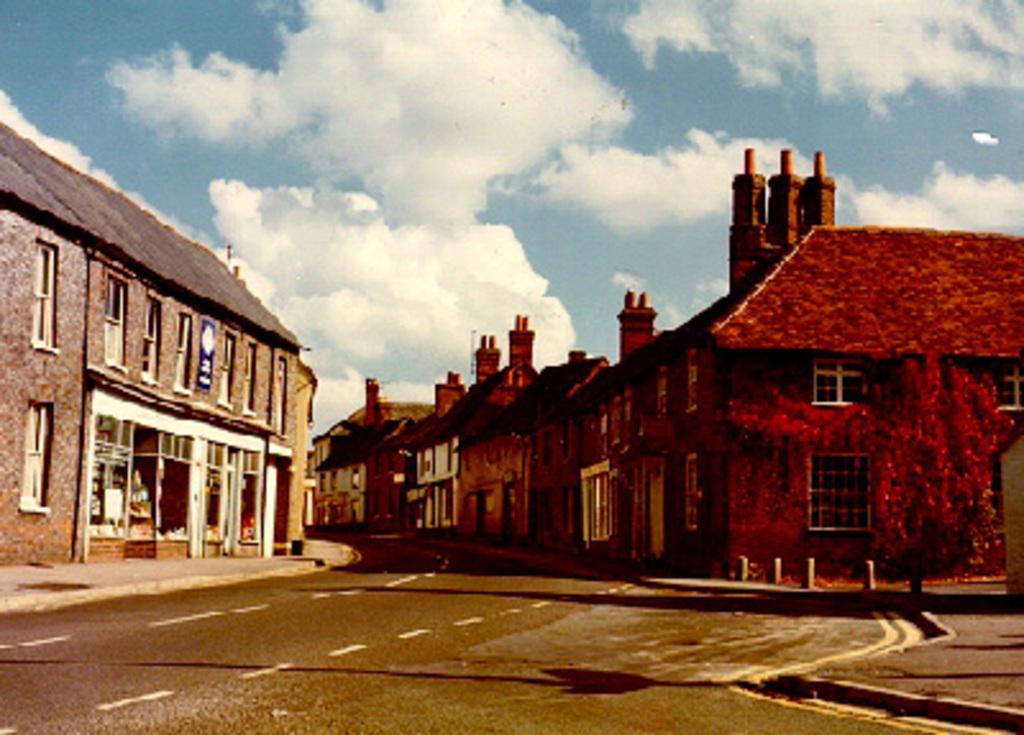Please provide a concise description of this image. As we can see in the image there are few houses. On the right side the houses are in red color and on the left side the houses are in brown color. On the top there is sky and clouds and in the front there is a road. 